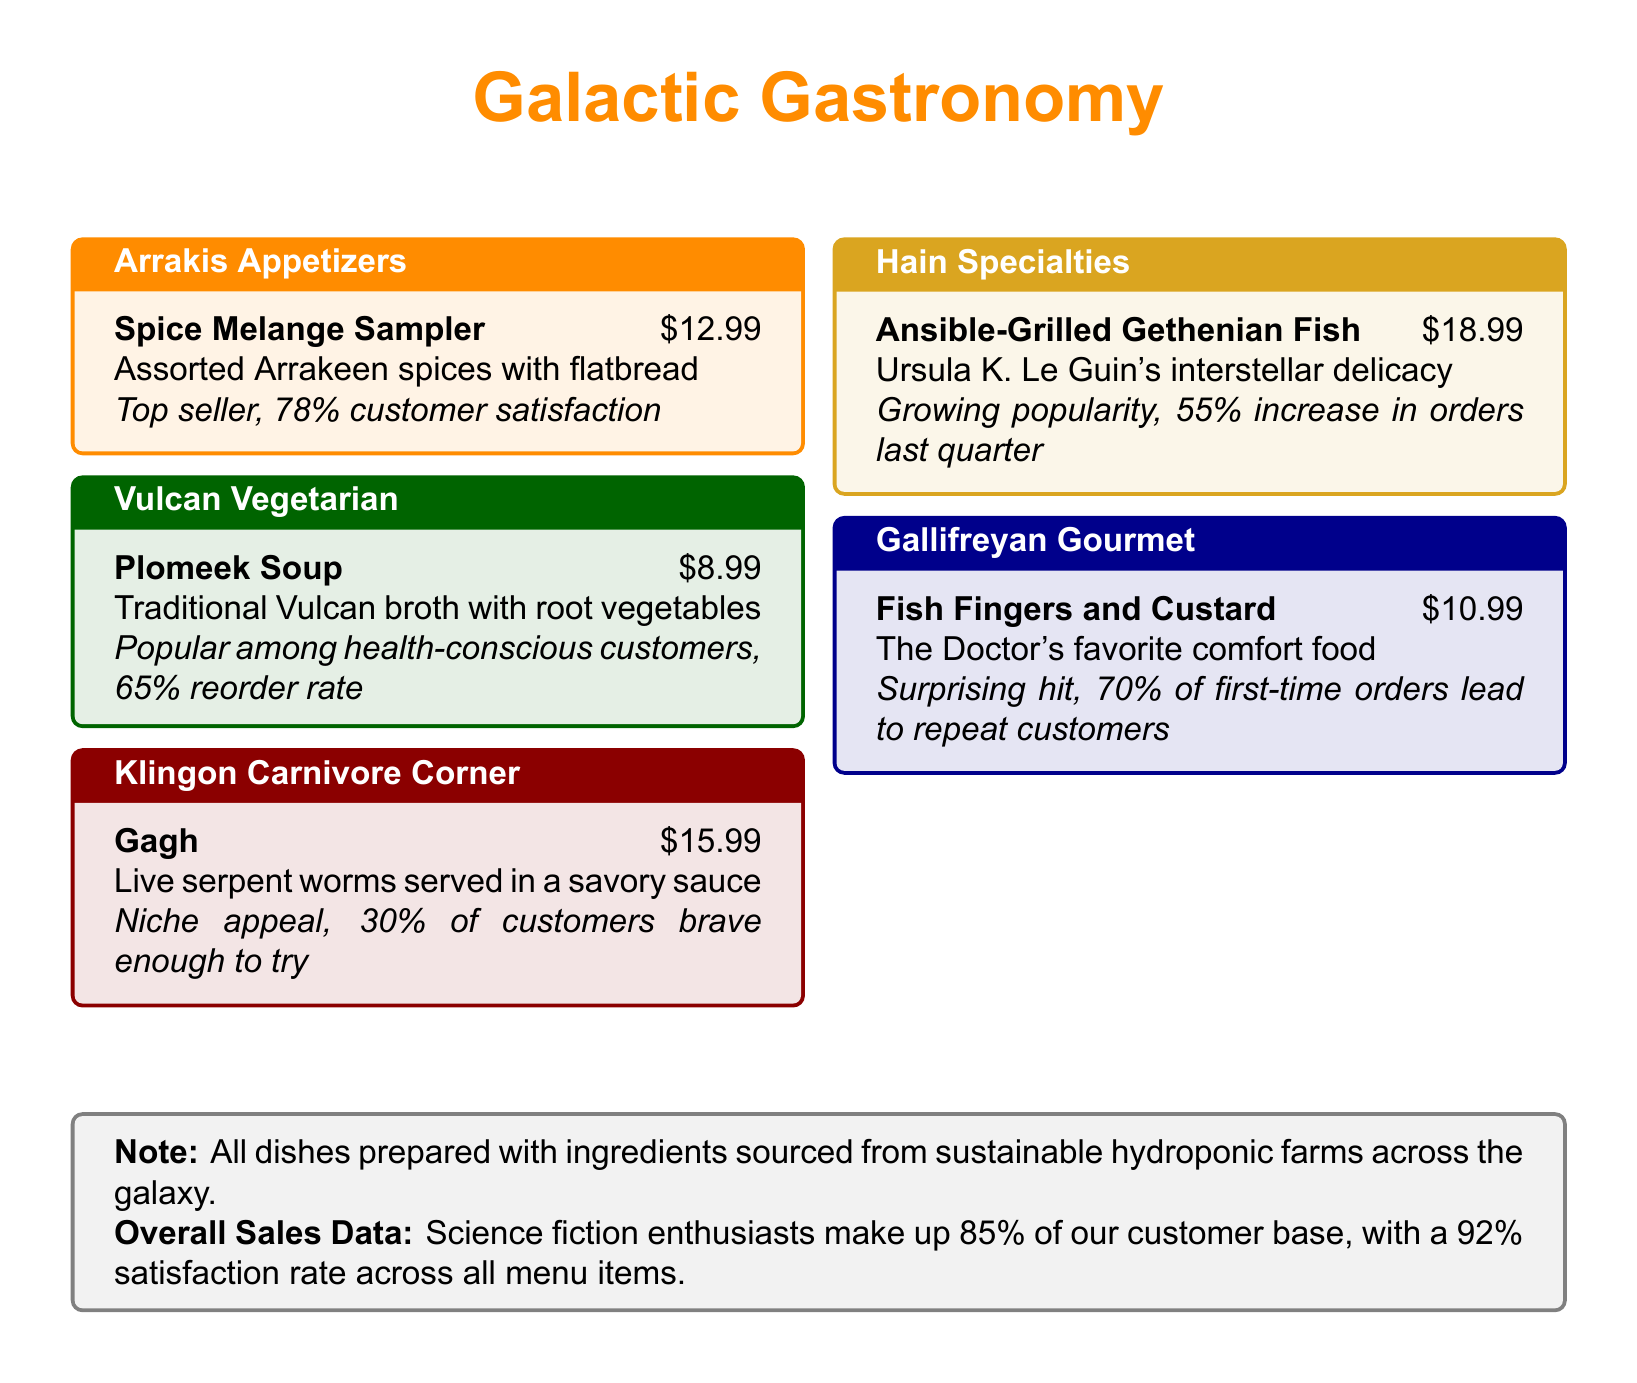What is the price of the Spice Melange Sampler? The price of the Spice Melange Sampler is listed on the menu under Arrakis Appetizers.
Answer: $12.99 What is the customer satisfaction percentage for Gagh? The document states that Gagh has a niche appeal with a specific percentage of customers brave enough to try it.
Answer: 30% Which dish has the highest price on the menu? The prices of all dishes are shown, and the highest one is identified.
Answer: Ansible-Grilled Gethenian Fish at $18.99 What percentage of the customer base are science fiction enthusiasts? The overall sales data section provides this specific percentage regarding the customer base.
Answer: 85% What is the reorder rate for Plomeek Soup? The document mentions a specific reorder rate for Plomeek Soup in the description.
Answer: 65% Which dish is described as a "surprising hit"? The menu highlights a particular dish that is referred to as a surprising hit.
Answer: Fish Fingers and Custard How much did orders for Ansible-Grilled Gethenian Fish increase last quarter? The menu provides a specific percentage increase for the orders of this dish.
Answer: 55% What color is used for the title of the Gallifreyan Gourmet section? The section color is noted in the document for visual reference.
Answer: Gallifreyan blue What is the overall satisfaction rate across all menu items? The overall satisfaction rate is mentioned in the overall sales data section of the document.
Answer: 92% 